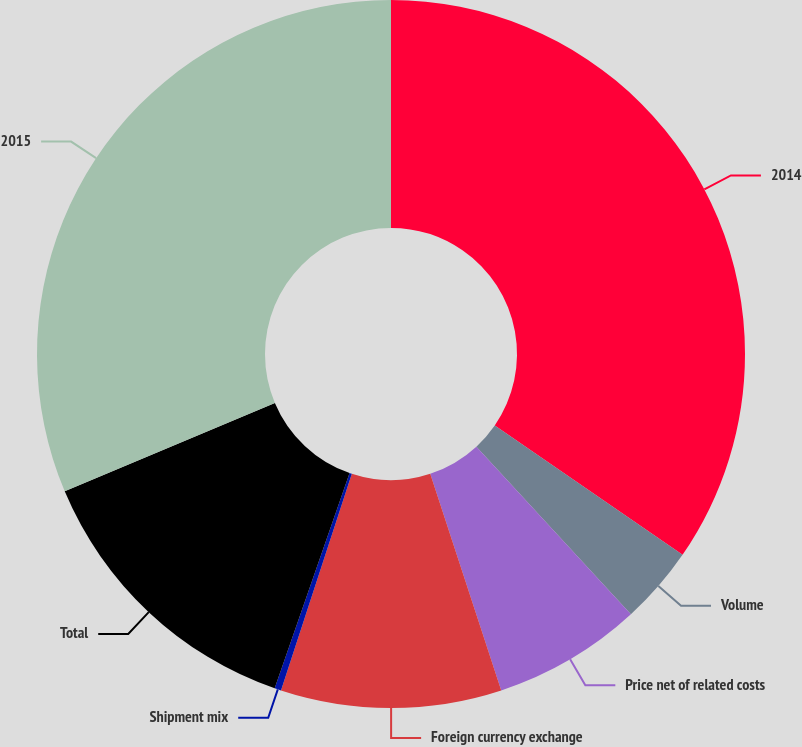Convert chart to OTSL. <chart><loc_0><loc_0><loc_500><loc_500><pie_chart><fcel>2014<fcel>Volume<fcel>Price net of related costs<fcel>Foreign currency exchange<fcel>Shipment mix<fcel>Total<fcel>2015<nl><fcel>34.6%<fcel>3.55%<fcel>6.81%<fcel>10.07%<fcel>0.3%<fcel>13.33%<fcel>31.34%<nl></chart> 